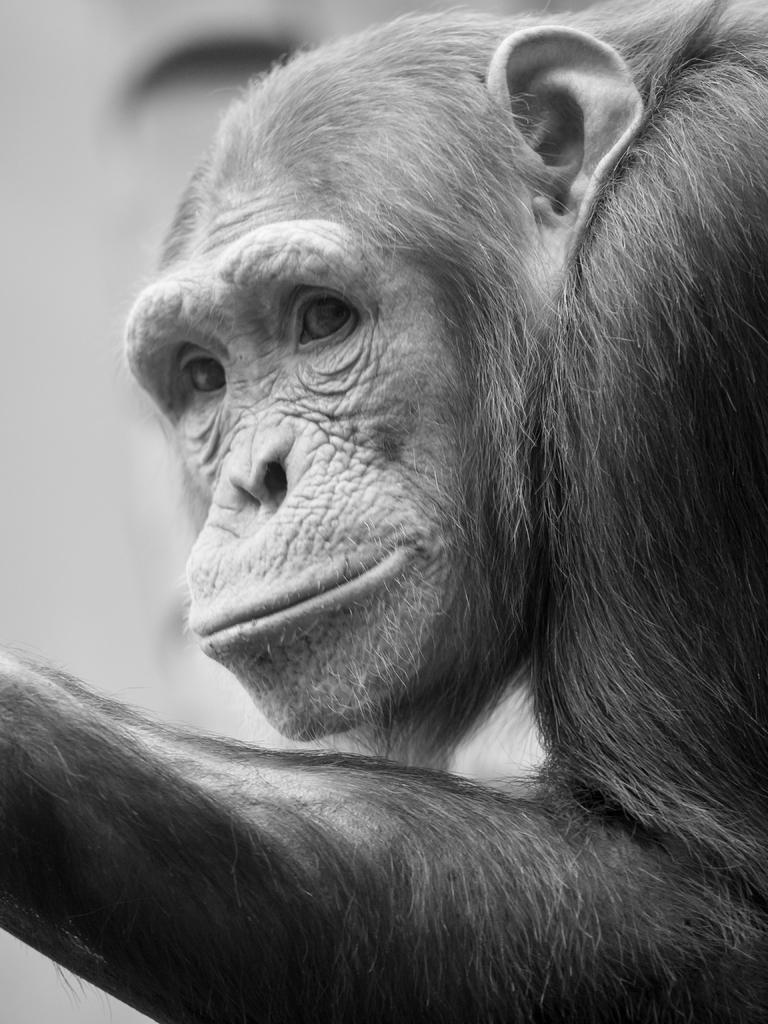What animal is present in the image? There is a monkey in the picture. What direction is the monkey looking in? The monkey is looking to the right. What can be seen in the background of the image? There is a wall in the background of the picture. What type of icicle can be seen hanging from the monkey's tail in the image? There is no icicle present in the image, and the monkey's tail is not visible. 